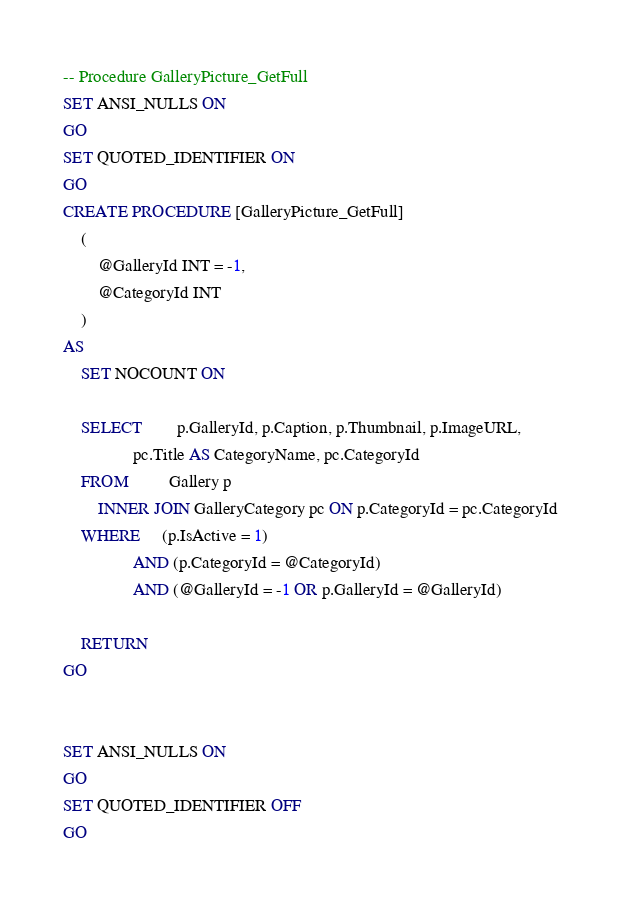Convert code to text. <code><loc_0><loc_0><loc_500><loc_500><_SQL_>
-- Procedure GalleryPicture_GetFull
SET ANSI_NULLS ON
GO
SET QUOTED_IDENTIFIER ON
GO
CREATE PROCEDURE [GalleryPicture_GetFull]
	(
		@GalleryId INT = -1,
		@CategoryId INT
	)
AS
	SET NOCOUNT ON
	
	SELECT		p.GalleryId, p.Caption, p.Thumbnail, p.ImageURL, 
				pc.Title AS CategoryName, pc.CategoryId
	FROM         Gallery p 
		INNER JOIN GalleryCategory pc ON p.CategoryId = pc.CategoryId
	WHERE     (p.IsActive = 1)
				AND (p.CategoryId = @CategoryId)
				AND (@GalleryId = -1 OR p.GalleryId = @GalleryId)
						
	RETURN
GO


SET ANSI_NULLS ON
GO
SET QUOTED_IDENTIFIER OFF
GO

</code> 